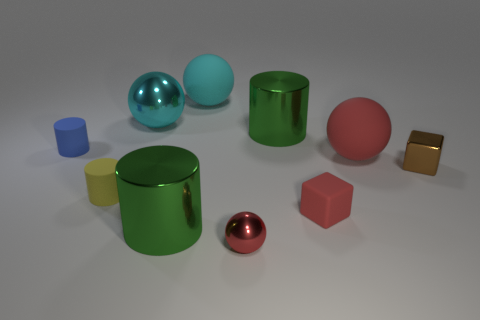Is the number of big cylinders that are to the right of the metallic block greater than the number of metal balls right of the tiny red ball?
Ensure brevity in your answer.  No. What material is the green object to the right of the red ball in front of the tiny cylinder in front of the metallic cube made of?
Your answer should be compact. Metal. The small yellow object that is the same material as the large red thing is what shape?
Ensure brevity in your answer.  Cylinder. Are there any blue cylinders on the right side of the large cylinder left of the large cyan rubber sphere?
Offer a very short reply. No. What is the size of the cyan shiny object?
Make the answer very short. Large. How many objects are blue rubber objects or brown things?
Your answer should be compact. 2. Is the red sphere to the left of the large red sphere made of the same material as the large green cylinder behind the small red matte block?
Your answer should be very brief. Yes. There is a sphere that is the same material as the large red thing; what color is it?
Offer a very short reply. Cyan. How many red shiny things have the same size as the yellow thing?
Keep it short and to the point. 1. How many other objects are there of the same color as the matte block?
Provide a succinct answer. 2. 